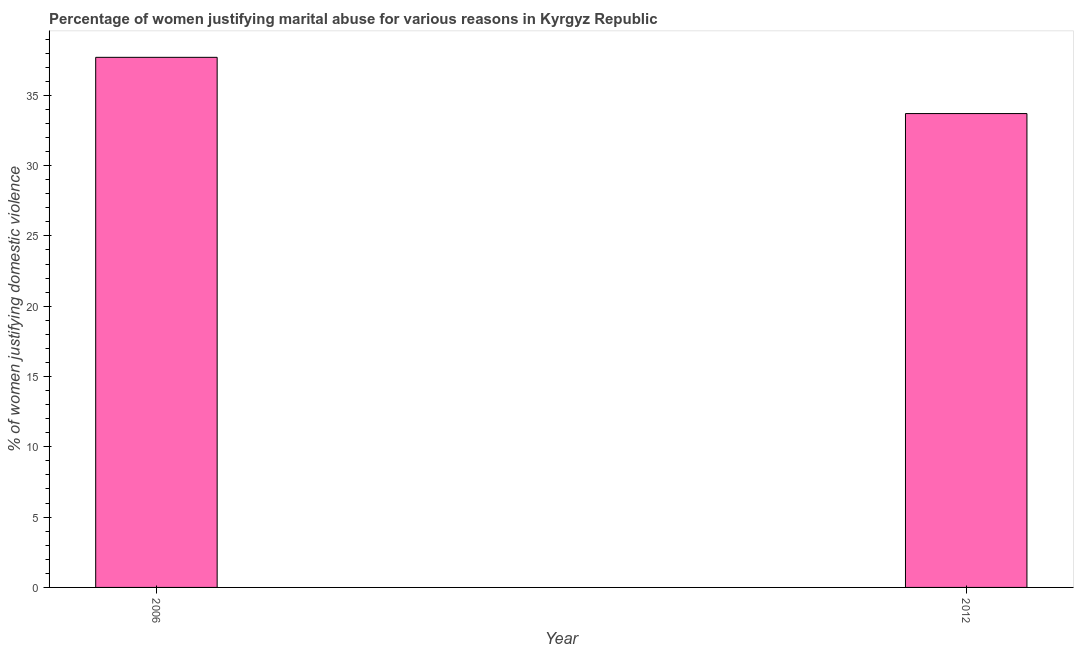Does the graph contain grids?
Your response must be concise. No. What is the title of the graph?
Make the answer very short. Percentage of women justifying marital abuse for various reasons in Kyrgyz Republic. What is the label or title of the X-axis?
Provide a succinct answer. Year. What is the label or title of the Y-axis?
Offer a terse response. % of women justifying domestic violence. What is the percentage of women justifying marital abuse in 2006?
Your answer should be compact. 37.7. Across all years, what is the maximum percentage of women justifying marital abuse?
Your response must be concise. 37.7. Across all years, what is the minimum percentage of women justifying marital abuse?
Provide a short and direct response. 33.7. In which year was the percentage of women justifying marital abuse maximum?
Your answer should be very brief. 2006. In which year was the percentage of women justifying marital abuse minimum?
Provide a succinct answer. 2012. What is the sum of the percentage of women justifying marital abuse?
Ensure brevity in your answer.  71.4. What is the difference between the percentage of women justifying marital abuse in 2006 and 2012?
Ensure brevity in your answer.  4. What is the average percentage of women justifying marital abuse per year?
Make the answer very short. 35.7. What is the median percentage of women justifying marital abuse?
Provide a short and direct response. 35.7. What is the ratio of the percentage of women justifying marital abuse in 2006 to that in 2012?
Keep it short and to the point. 1.12. In how many years, is the percentage of women justifying marital abuse greater than the average percentage of women justifying marital abuse taken over all years?
Offer a very short reply. 1. How many years are there in the graph?
Offer a very short reply. 2. Are the values on the major ticks of Y-axis written in scientific E-notation?
Ensure brevity in your answer.  No. What is the % of women justifying domestic violence of 2006?
Ensure brevity in your answer.  37.7. What is the % of women justifying domestic violence in 2012?
Your answer should be compact. 33.7. What is the difference between the % of women justifying domestic violence in 2006 and 2012?
Provide a short and direct response. 4. What is the ratio of the % of women justifying domestic violence in 2006 to that in 2012?
Make the answer very short. 1.12. 